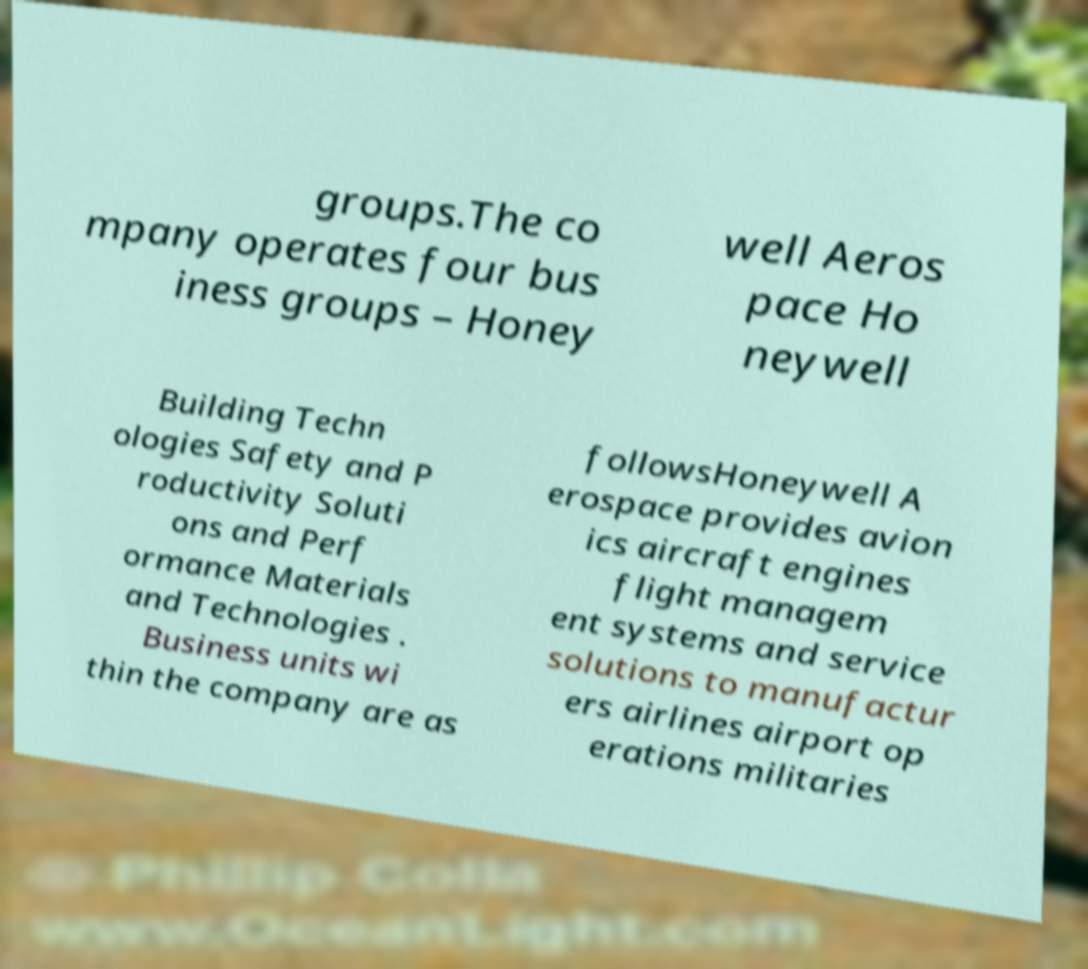What messages or text are displayed in this image? I need them in a readable, typed format. groups.The co mpany operates four bus iness groups – Honey well Aeros pace Ho neywell Building Techn ologies Safety and P roductivity Soluti ons and Perf ormance Materials and Technologies . Business units wi thin the company are as followsHoneywell A erospace provides avion ics aircraft engines flight managem ent systems and service solutions to manufactur ers airlines airport op erations militaries 